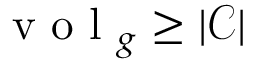<formula> <loc_0><loc_0><loc_500><loc_500>v o l _ { g } \geq | \mathcal { C } |</formula> 